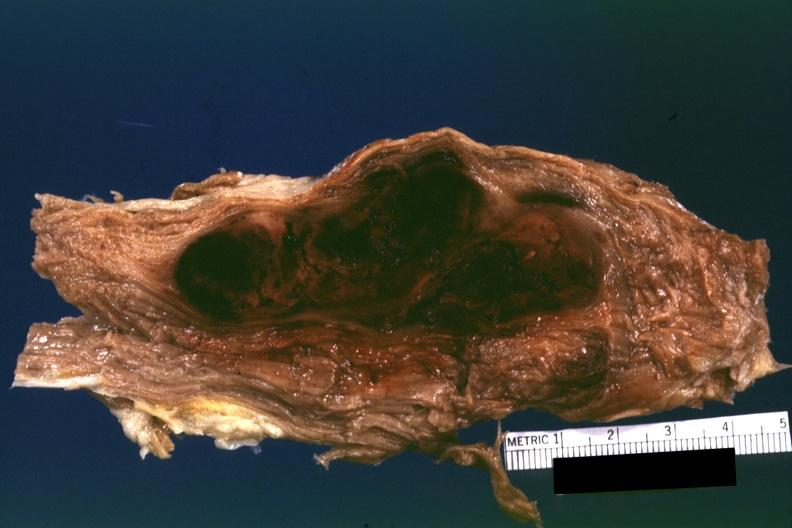what is present?
Answer the question using a single word or phrase. Soft tissue 